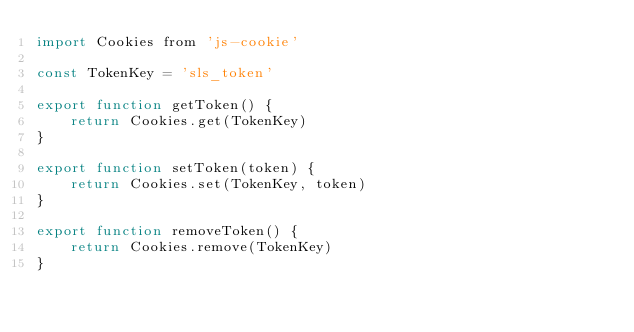Convert code to text. <code><loc_0><loc_0><loc_500><loc_500><_JavaScript_>import Cookies from 'js-cookie'

const TokenKey = 'sls_token'

export function getToken() {
    return Cookies.get(TokenKey)
}

export function setToken(token) {
    return Cookies.set(TokenKey, token)
}

export function removeToken() {
    return Cookies.remove(TokenKey)
}</code> 